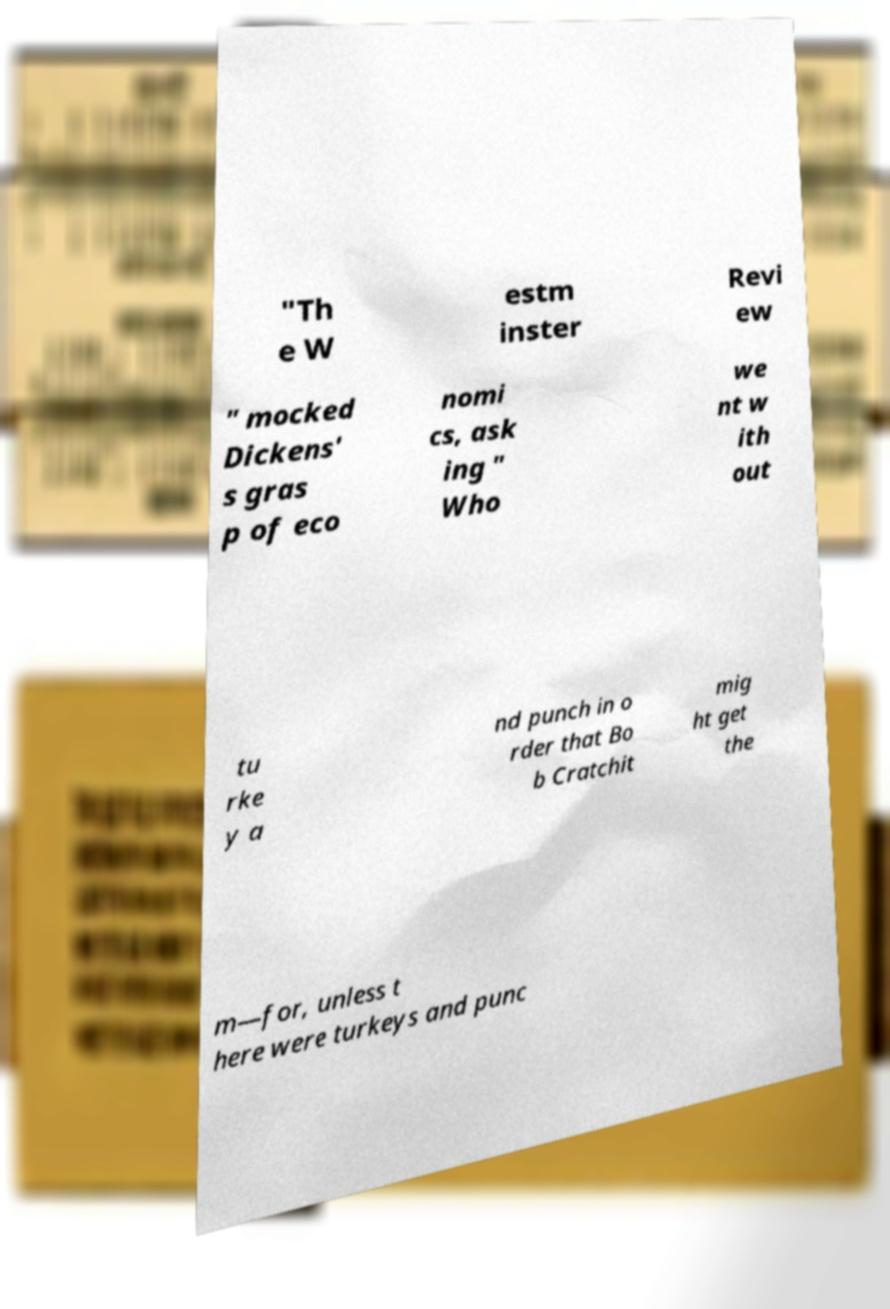I need the written content from this picture converted into text. Can you do that? "Th e W estm inster Revi ew " mocked Dickens' s gras p of eco nomi cs, ask ing " Who we nt w ith out tu rke y a nd punch in o rder that Bo b Cratchit mig ht get the m—for, unless t here were turkeys and punc 